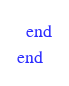Convert code to text. <code><loc_0><loc_0><loc_500><loc_500><_Ruby_>  end
end
</code> 